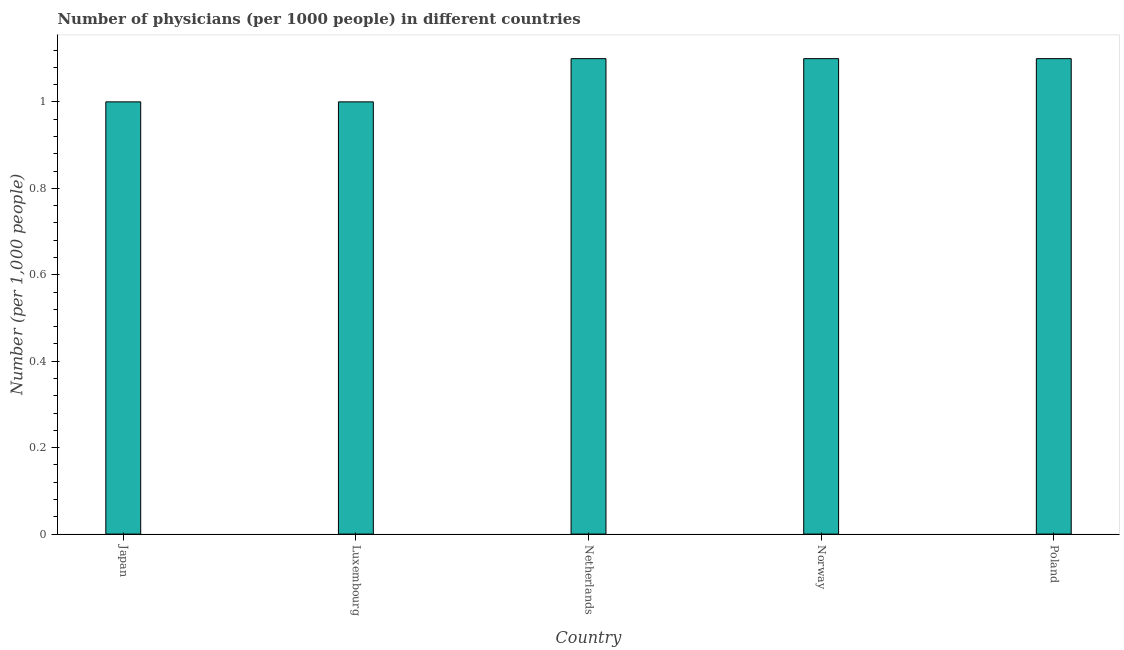What is the title of the graph?
Your answer should be very brief. Number of physicians (per 1000 people) in different countries. What is the label or title of the X-axis?
Give a very brief answer. Country. What is the label or title of the Y-axis?
Your response must be concise. Number (per 1,0 people). In which country was the number of physicians minimum?
Ensure brevity in your answer.  Japan. What is the sum of the number of physicians?
Your answer should be very brief. 5.3. What is the difference between the number of physicians in Luxembourg and Poland?
Keep it short and to the point. -0.1. What is the average number of physicians per country?
Keep it short and to the point. 1.06. What is the ratio of the number of physicians in Japan to that in Poland?
Ensure brevity in your answer.  0.91. Is the number of physicians in Norway less than that in Poland?
Give a very brief answer. No. Is the difference between the number of physicians in Luxembourg and Netherlands greater than the difference between any two countries?
Your response must be concise. Yes. Is the sum of the number of physicians in Luxembourg and Poland greater than the maximum number of physicians across all countries?
Provide a short and direct response. Yes. In how many countries, is the number of physicians greater than the average number of physicians taken over all countries?
Provide a succinct answer. 3. How many bars are there?
Provide a short and direct response. 5. Are all the bars in the graph horizontal?
Offer a very short reply. No. What is the difference between two consecutive major ticks on the Y-axis?
Offer a terse response. 0.2. Are the values on the major ticks of Y-axis written in scientific E-notation?
Your answer should be compact. No. What is the Number (per 1,000 people) in Japan?
Provide a succinct answer. 1. What is the Number (per 1,000 people) in Luxembourg?
Ensure brevity in your answer.  1. What is the Number (per 1,000 people) of Netherlands?
Your response must be concise. 1.1. What is the Number (per 1,000 people) in Norway?
Your response must be concise. 1.1. What is the difference between the Number (per 1,000 people) in Japan and Netherlands?
Make the answer very short. -0.1. What is the difference between the Number (per 1,000 people) in Japan and Norway?
Make the answer very short. -0.1. What is the ratio of the Number (per 1,000 people) in Japan to that in Netherlands?
Offer a terse response. 0.91. What is the ratio of the Number (per 1,000 people) in Japan to that in Norway?
Offer a terse response. 0.91. What is the ratio of the Number (per 1,000 people) in Japan to that in Poland?
Offer a very short reply. 0.91. What is the ratio of the Number (per 1,000 people) in Luxembourg to that in Netherlands?
Make the answer very short. 0.91. What is the ratio of the Number (per 1,000 people) in Luxembourg to that in Norway?
Your response must be concise. 0.91. What is the ratio of the Number (per 1,000 people) in Luxembourg to that in Poland?
Your answer should be very brief. 0.91. What is the ratio of the Number (per 1,000 people) in Netherlands to that in Norway?
Your response must be concise. 1. What is the ratio of the Number (per 1,000 people) in Netherlands to that in Poland?
Your response must be concise. 1. 